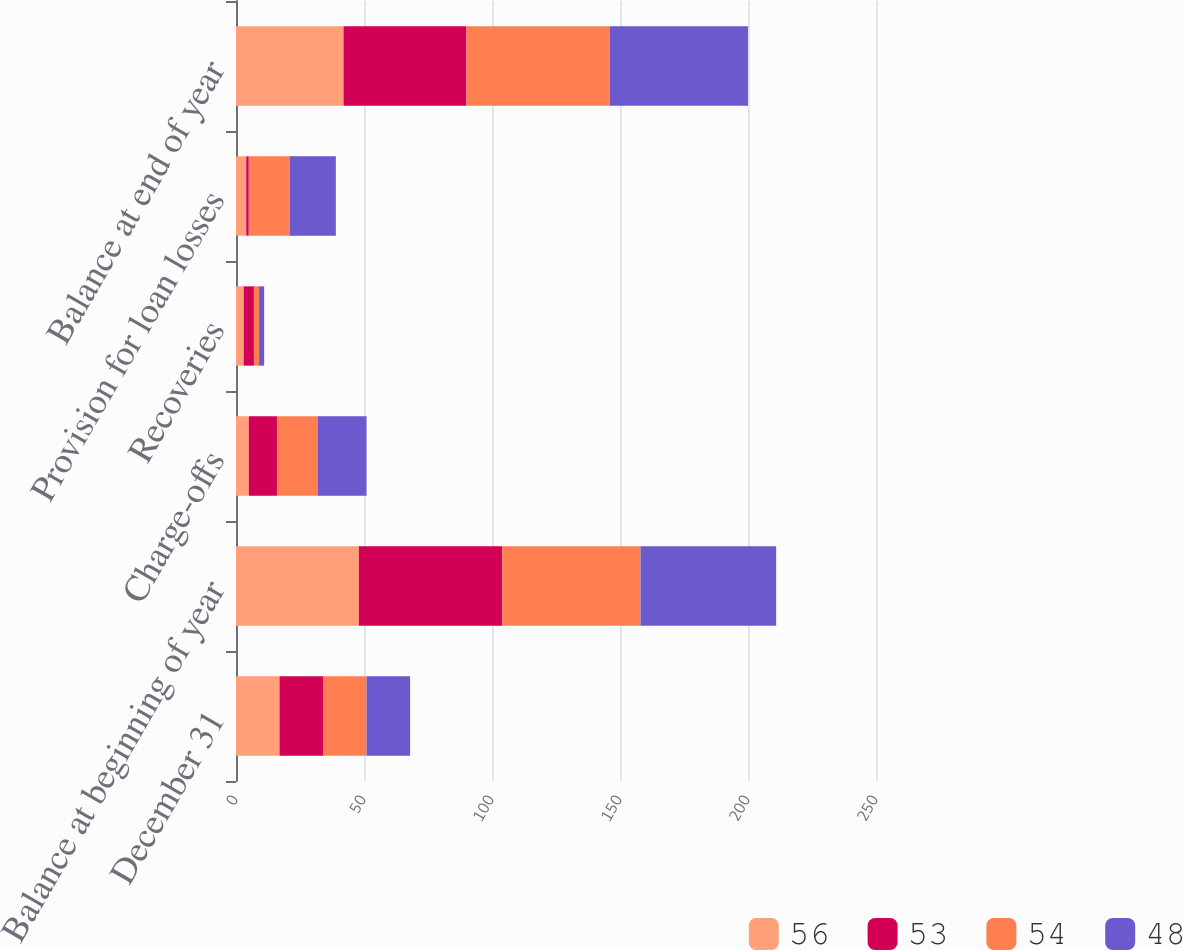Convert chart. <chart><loc_0><loc_0><loc_500><loc_500><stacked_bar_chart><ecel><fcel>December 31<fcel>Balance at beginning of year<fcel>Charge-offs<fcel>Recoveries<fcel>Provision for loan losses<fcel>Balance at end of year<nl><fcel>56<fcel>17<fcel>48<fcel>5<fcel>3<fcel>4<fcel>42<nl><fcel>53<fcel>17<fcel>56<fcel>11<fcel>4<fcel>1<fcel>48<nl><fcel>54<fcel>17<fcel>54<fcel>16<fcel>2<fcel>16<fcel>56<nl><fcel>48<fcel>17<fcel>53<fcel>19<fcel>2<fcel>18<fcel>54<nl></chart> 